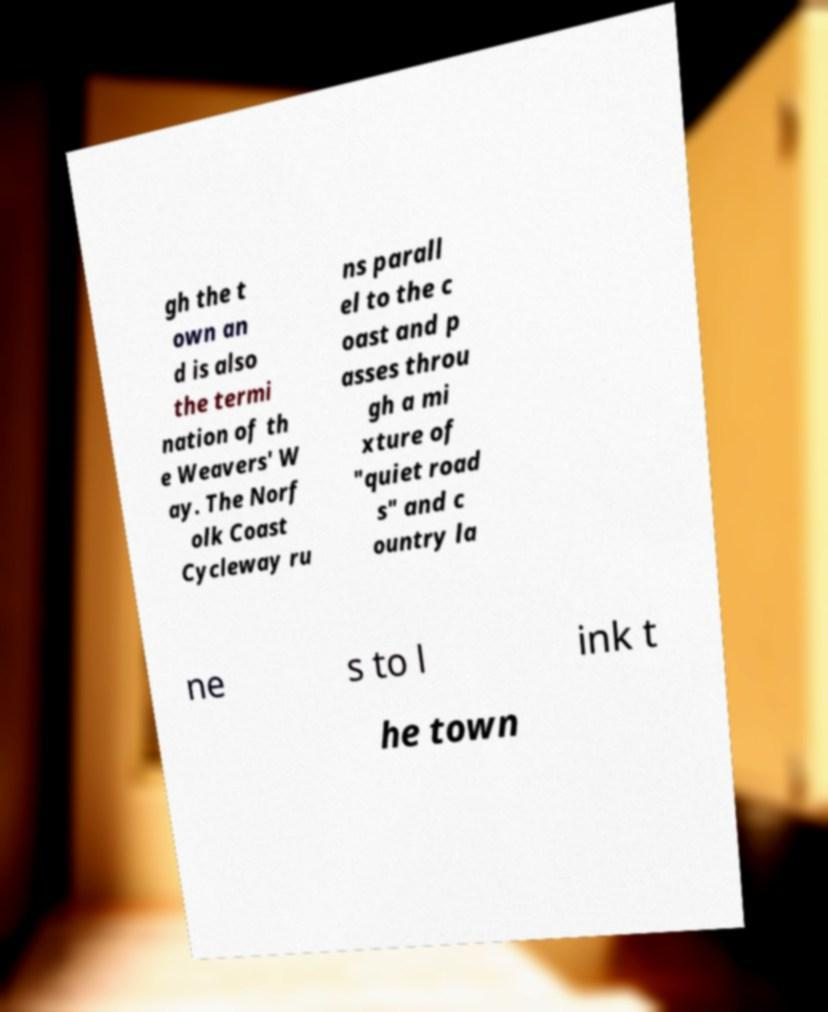Could you assist in decoding the text presented in this image and type it out clearly? gh the t own an d is also the termi nation of th e Weavers' W ay. The Norf olk Coast Cycleway ru ns parall el to the c oast and p asses throu gh a mi xture of "quiet road s" and c ountry la ne s to l ink t he town 